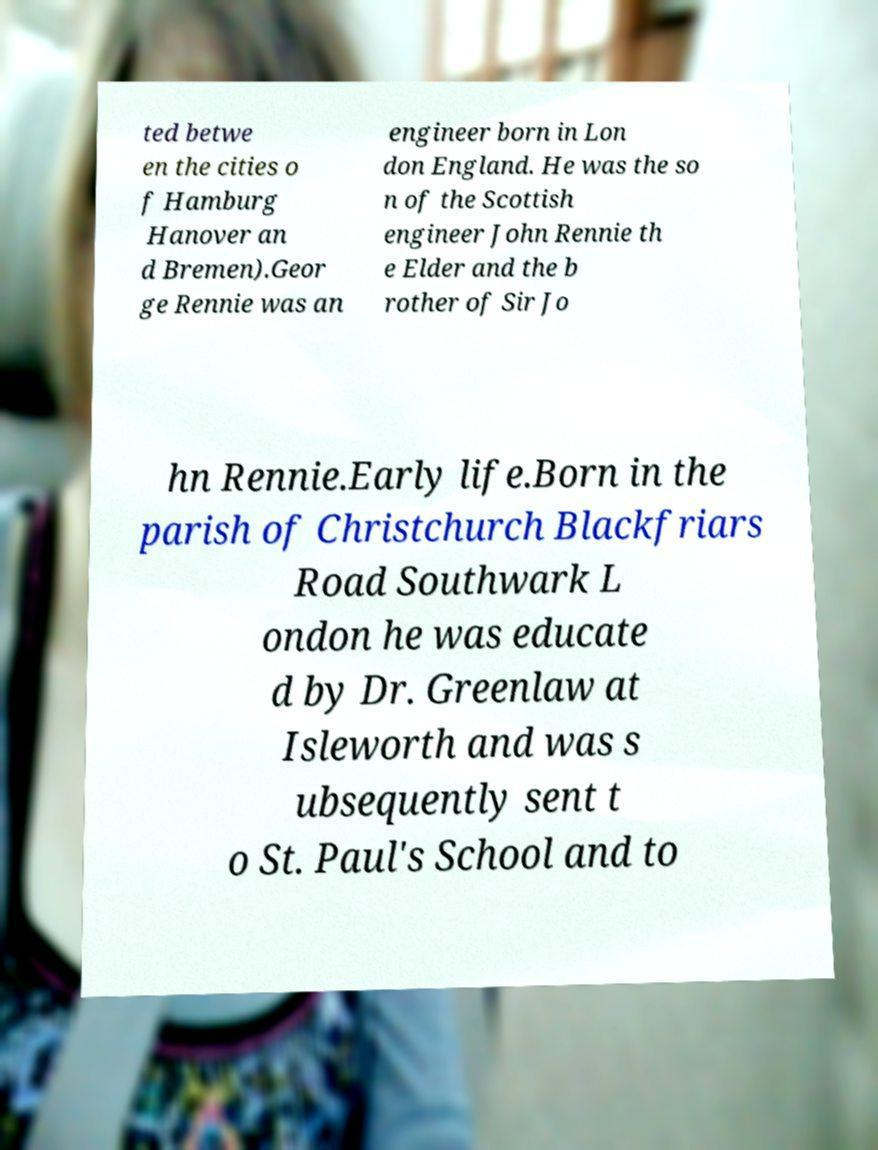Can you read and provide the text displayed in the image?This photo seems to have some interesting text. Can you extract and type it out for me? ted betwe en the cities o f Hamburg Hanover an d Bremen).Geor ge Rennie was an engineer born in Lon don England. He was the so n of the Scottish engineer John Rennie th e Elder and the b rother of Sir Jo hn Rennie.Early life.Born in the parish of Christchurch Blackfriars Road Southwark L ondon he was educate d by Dr. Greenlaw at Isleworth and was s ubsequently sent t o St. Paul's School and to 